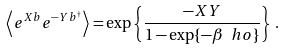<formula> <loc_0><loc_0><loc_500><loc_500>\left \langle e ^ { X b } e ^ { - Y b ^ { \dagger } } \right \rangle = \exp \left \{ \frac { - X Y } { 1 - \exp \{ - \beta \ h o \} } \right \} \, .</formula> 